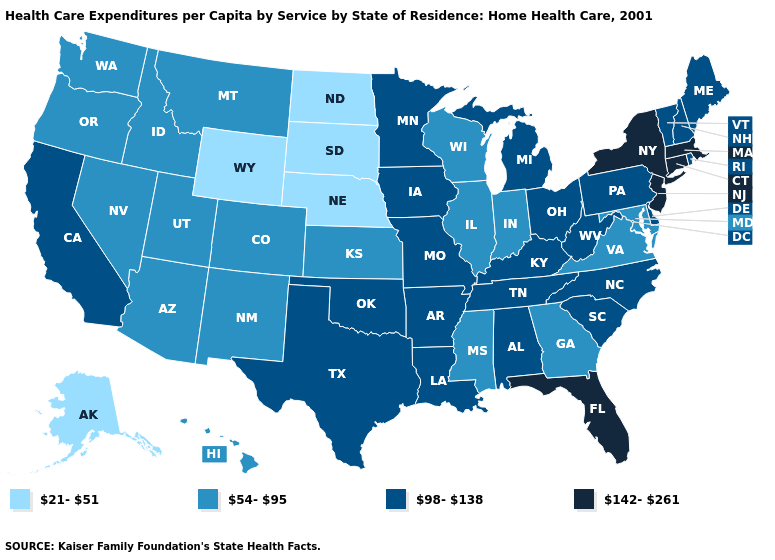What is the value of Alabama?
Give a very brief answer. 98-138. Name the states that have a value in the range 98-138?
Short answer required. Alabama, Arkansas, California, Delaware, Iowa, Kentucky, Louisiana, Maine, Michigan, Minnesota, Missouri, New Hampshire, North Carolina, Ohio, Oklahoma, Pennsylvania, Rhode Island, South Carolina, Tennessee, Texas, Vermont, West Virginia. What is the lowest value in the MidWest?
Keep it brief. 21-51. Among the states that border Maryland , does Pennsylvania have the highest value?
Quick response, please. Yes. Which states have the lowest value in the USA?
Write a very short answer. Alaska, Nebraska, North Dakota, South Dakota, Wyoming. Does Alaska have the lowest value in the USA?
Concise answer only. Yes. Does Illinois have the highest value in the MidWest?
Write a very short answer. No. What is the value of New Jersey?
Be succinct. 142-261. Does Wyoming have the lowest value in the USA?
Quick response, please. Yes. Does Massachusetts have the highest value in the USA?
Short answer required. Yes. Among the states that border Alabama , does Mississippi have the lowest value?
Give a very brief answer. Yes. Name the states that have a value in the range 54-95?
Concise answer only. Arizona, Colorado, Georgia, Hawaii, Idaho, Illinois, Indiana, Kansas, Maryland, Mississippi, Montana, Nevada, New Mexico, Oregon, Utah, Virginia, Washington, Wisconsin. Name the states that have a value in the range 21-51?
Answer briefly. Alaska, Nebraska, North Dakota, South Dakota, Wyoming. Which states have the lowest value in the USA?
Be succinct. Alaska, Nebraska, North Dakota, South Dakota, Wyoming. Name the states that have a value in the range 54-95?
Give a very brief answer. Arizona, Colorado, Georgia, Hawaii, Idaho, Illinois, Indiana, Kansas, Maryland, Mississippi, Montana, Nevada, New Mexico, Oregon, Utah, Virginia, Washington, Wisconsin. 